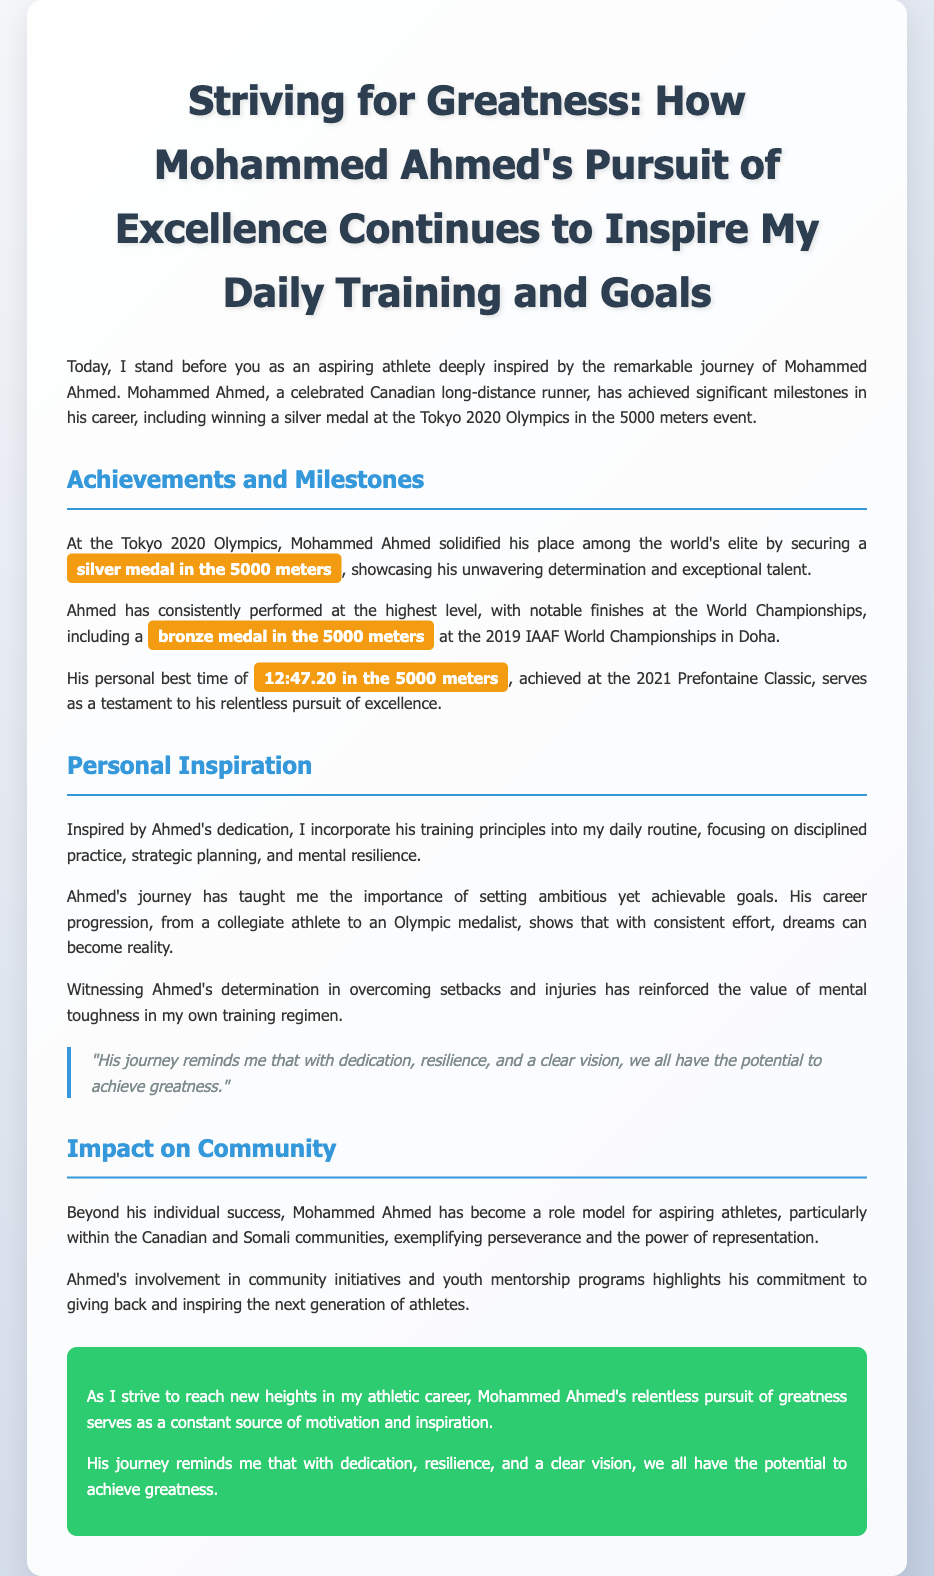What medal did Mohammed Ahmed win at the Tokyo 2020 Olympics? The document states that Mohammed Ahmed secured a silver medal in the 5000 meters at the Tokyo 2020 Olympics.
Answer: silver medal What was Mohammed Ahmed's personal best time in the 5000 meters? According to the document, Ahmed's personal best time of 12:47.20 was achieved at the 2021 Prefontaine Classic.
Answer: 12:47.20 What community does Mohammed Ahmed particularly inspire? The document highlights that Ahmed serves as a role model for aspiring athletes within the Canadian and Somali communities.
Answer: Canadian and Somali communities What does the speaker incorporate into their daily routine from Ahmed's training principles? The document mentions that the speaker incorporates disciplined practice, strategic planning, and mental resilience from Ahmed's training principles.
Answer: disciplined practice, strategic planning, and mental resilience What is the overall theme of the eulogy? The theme focuses on Mohammed Ahmed's relentless pursuit of greatness and its impact on the speaker's athletic aspirations.
Answer: relentless pursuit of greatness 